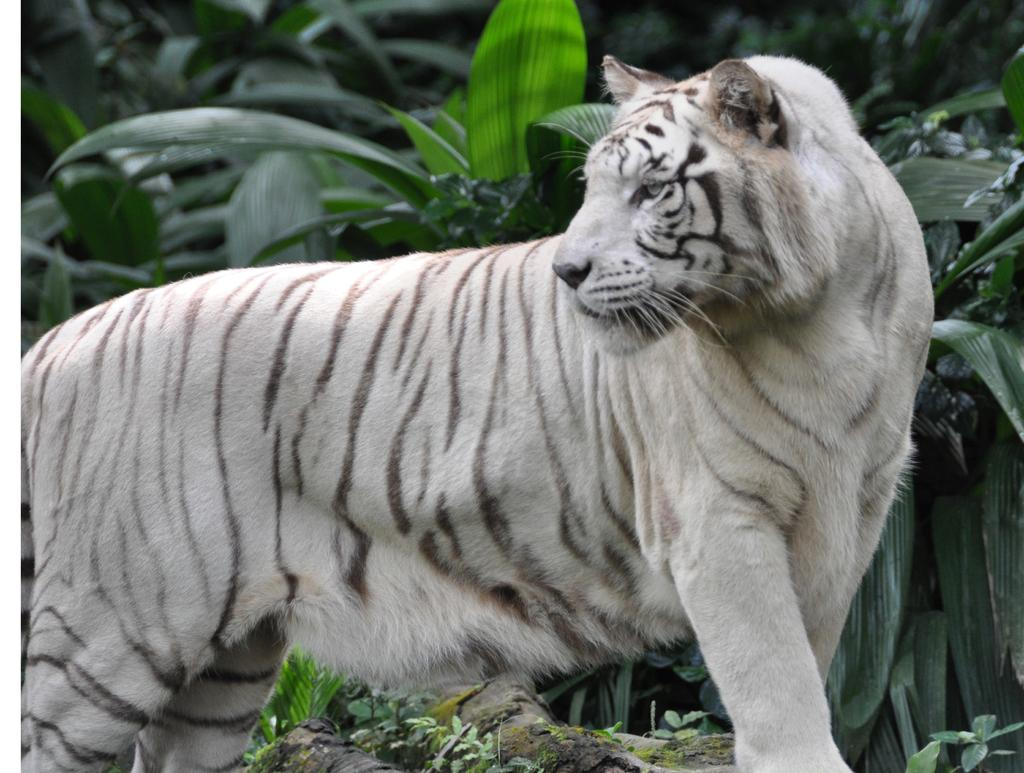What animal is standing in the image? There is a tiger standing in the image. What type of vegetation can be seen in the image? There are plants visible in the image. Can you describe any other features at the bottom of the image? There might be a tree branch at the bottom of the image. What letter is the tiger holding in the image? There is no letter present in the image; the tiger is not holding anything. 